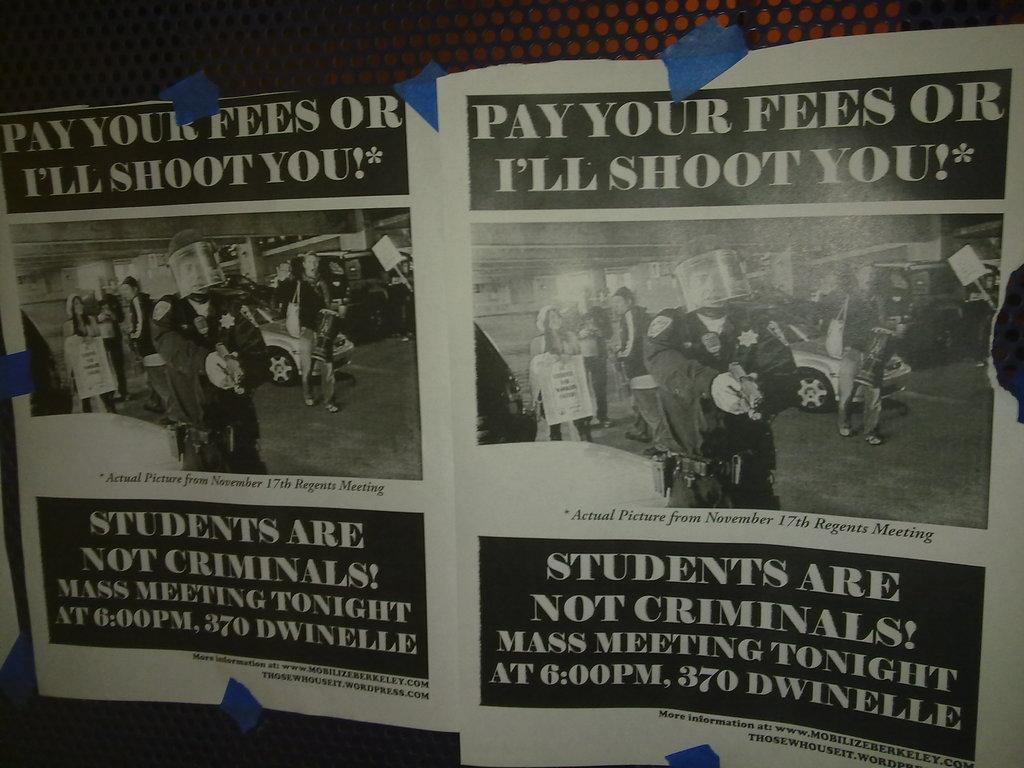What happens if you don't pay your fees?
Provide a succinct answer. I'll shoot you. Who are not criminals?
Your answer should be very brief. Students. 